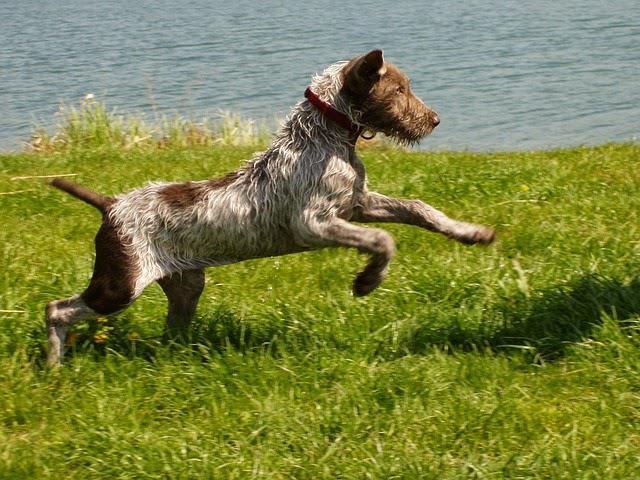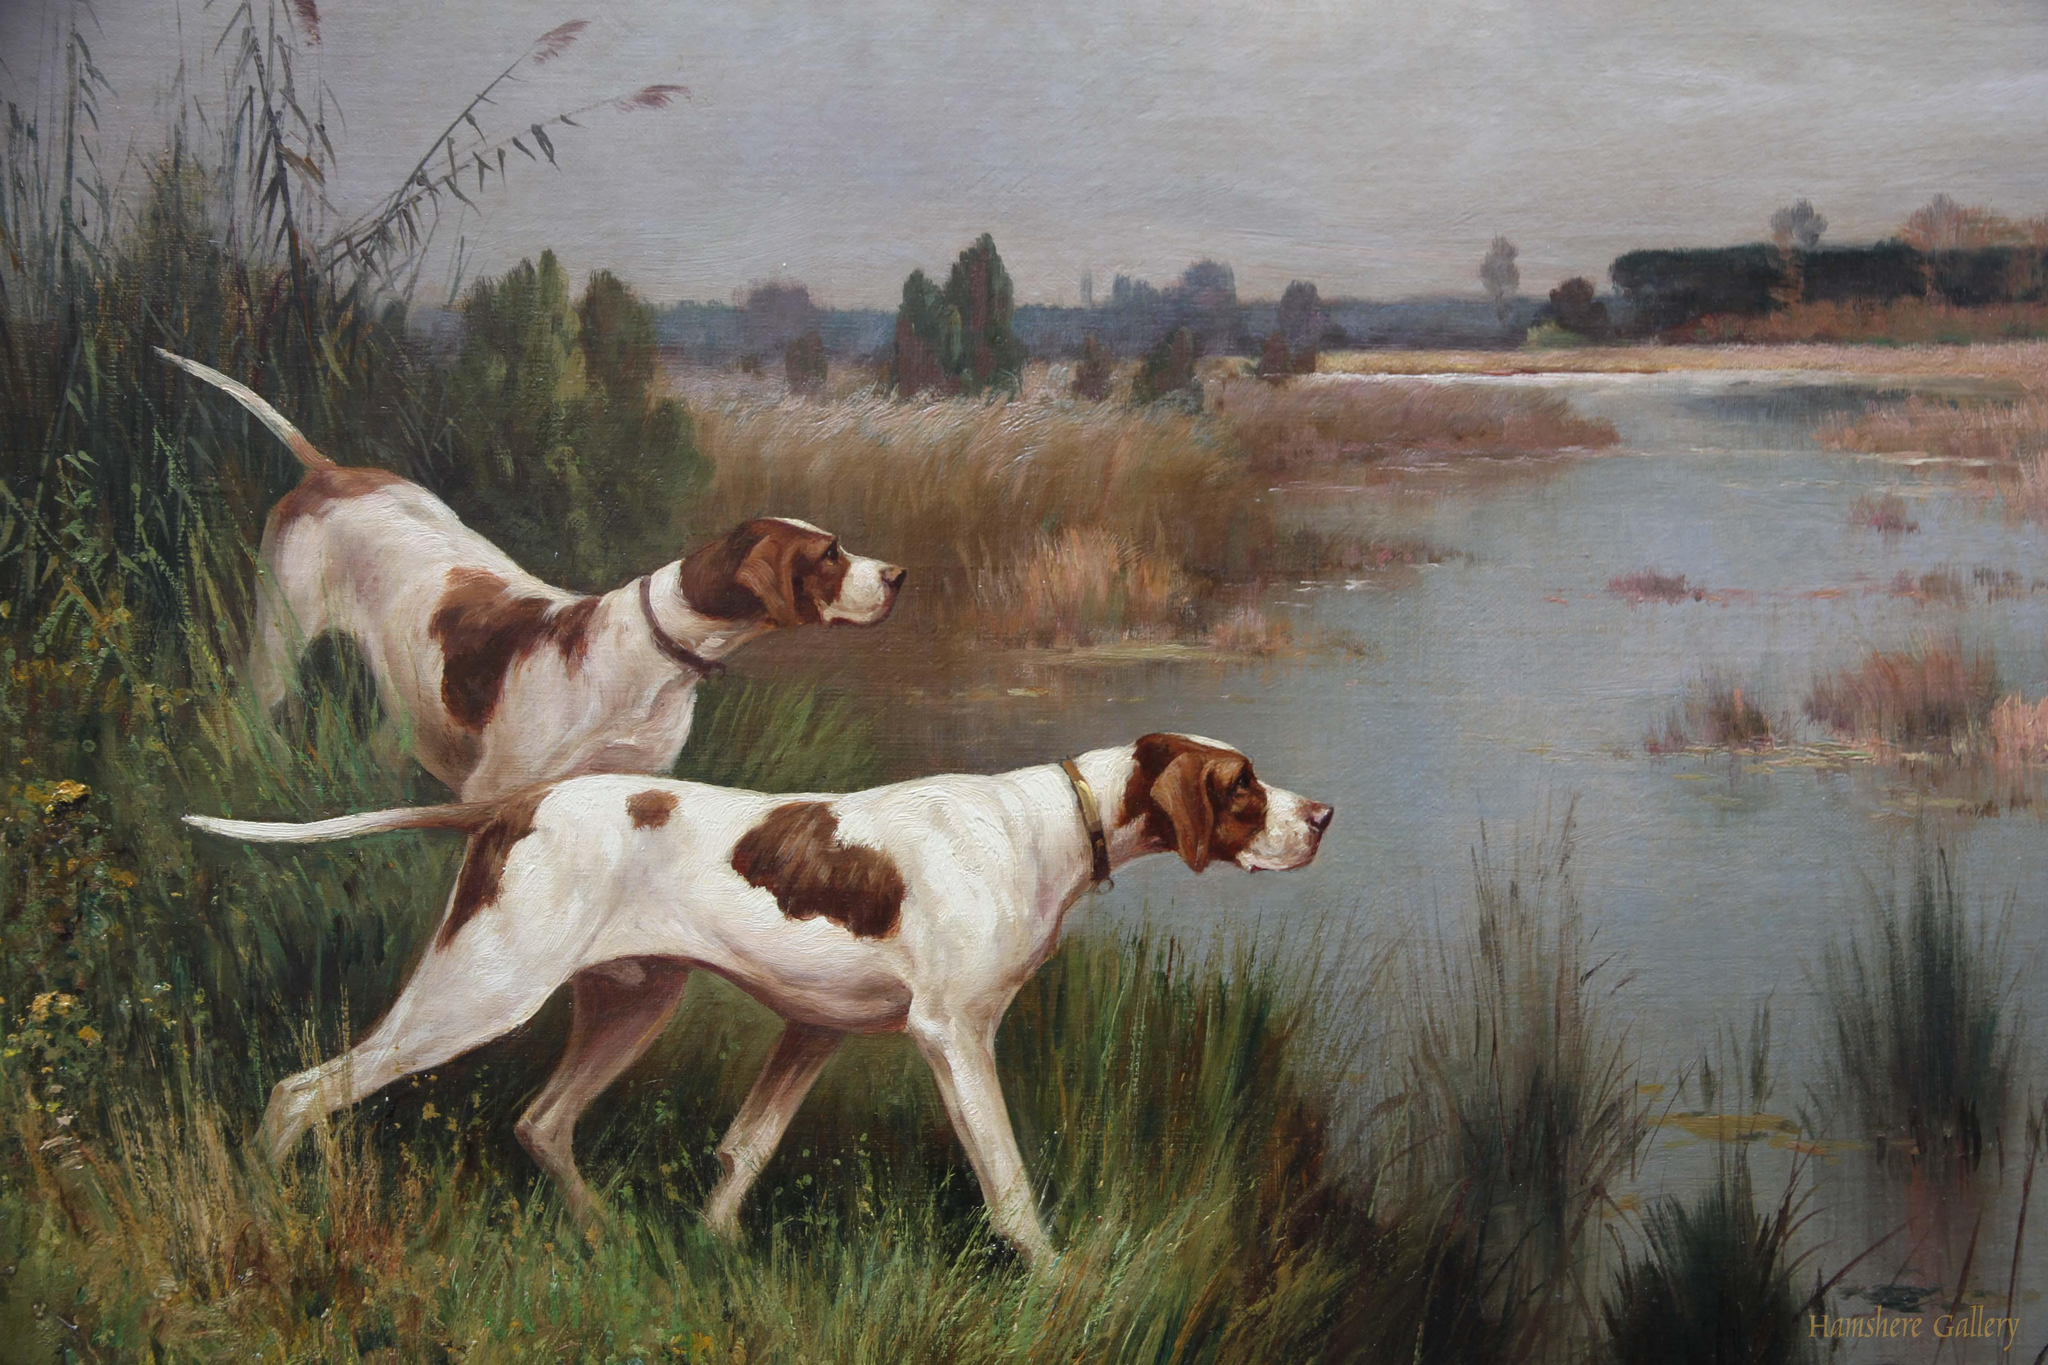The first image is the image on the left, the second image is the image on the right. Analyze the images presented: Is the assertion "There is the same number of dogs in both images." valid? Answer yes or no. No. The first image is the image on the left, the second image is the image on the right. Evaluate the accuracy of this statement regarding the images: "Each image includes one hound in a standing position, and the dog on the left is black-and-white with an open mouth and tail sticking out.". Is it true? Answer yes or no. No. 